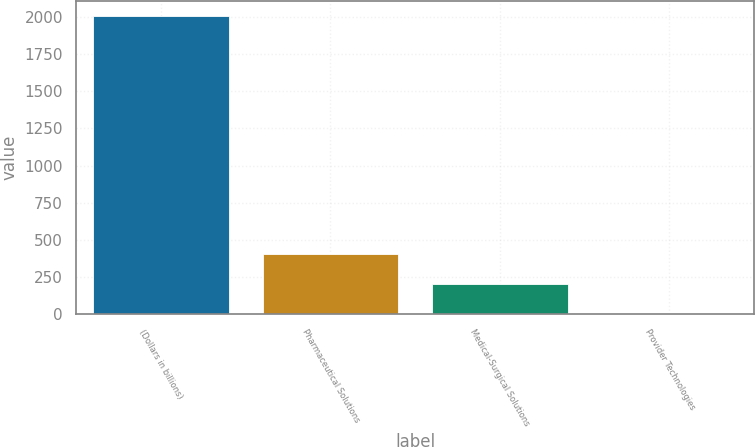Convert chart. <chart><loc_0><loc_0><loc_500><loc_500><bar_chart><fcel>(Dollars in billions)<fcel>Pharmaceutical Solutions<fcel>Medical-Surgical Solutions<fcel>Provider Technologies<nl><fcel>2006<fcel>402.48<fcel>202.04<fcel>1.6<nl></chart> 